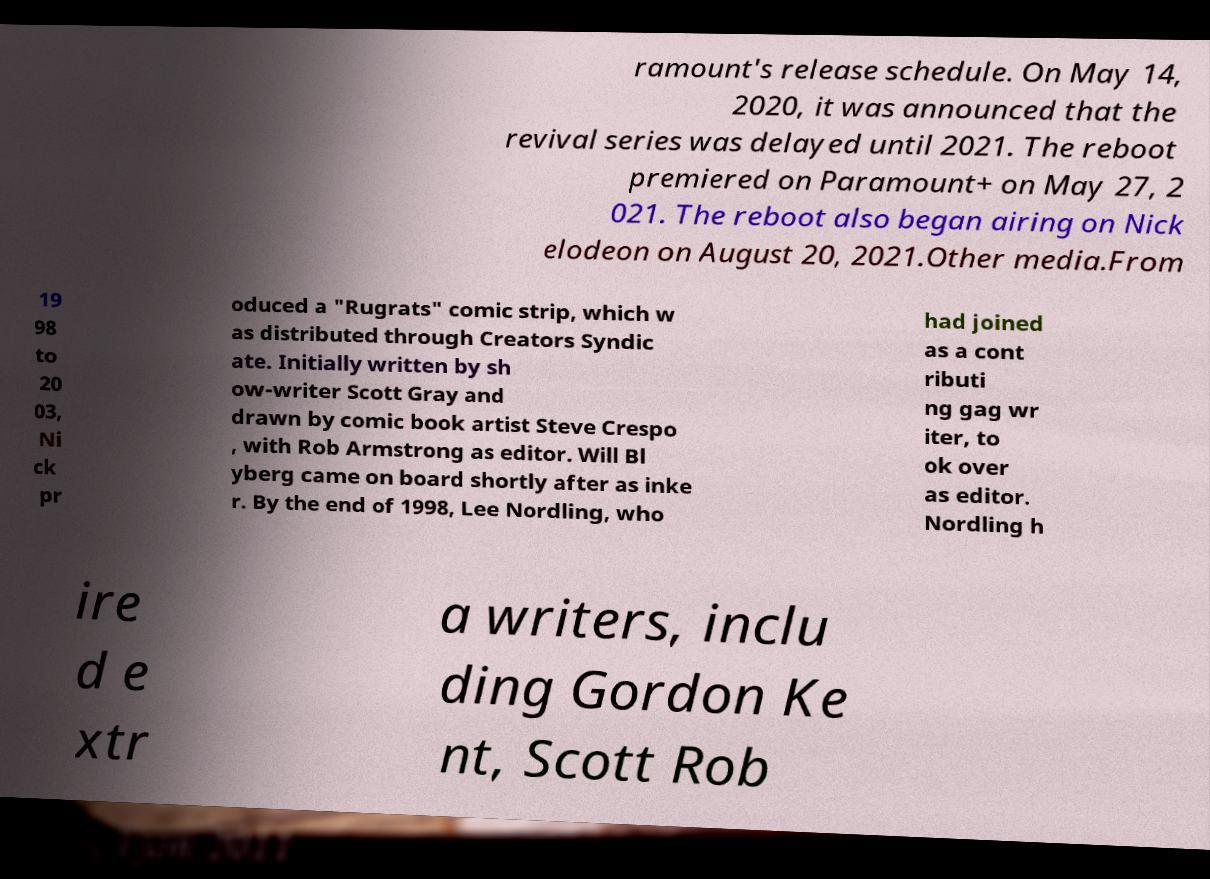Can you accurately transcribe the text from the provided image for me? ramount's release schedule. On May 14, 2020, it was announced that the revival series was delayed until 2021. The reboot premiered on Paramount+ on May 27, 2 021. The reboot also began airing on Nick elodeon on August 20, 2021.Other media.From 19 98 to 20 03, Ni ck pr oduced a "Rugrats" comic strip, which w as distributed through Creators Syndic ate. Initially written by sh ow-writer Scott Gray and drawn by comic book artist Steve Crespo , with Rob Armstrong as editor. Will Bl yberg came on board shortly after as inke r. By the end of 1998, Lee Nordling, who had joined as a cont ributi ng gag wr iter, to ok over as editor. Nordling h ire d e xtr a writers, inclu ding Gordon Ke nt, Scott Rob 